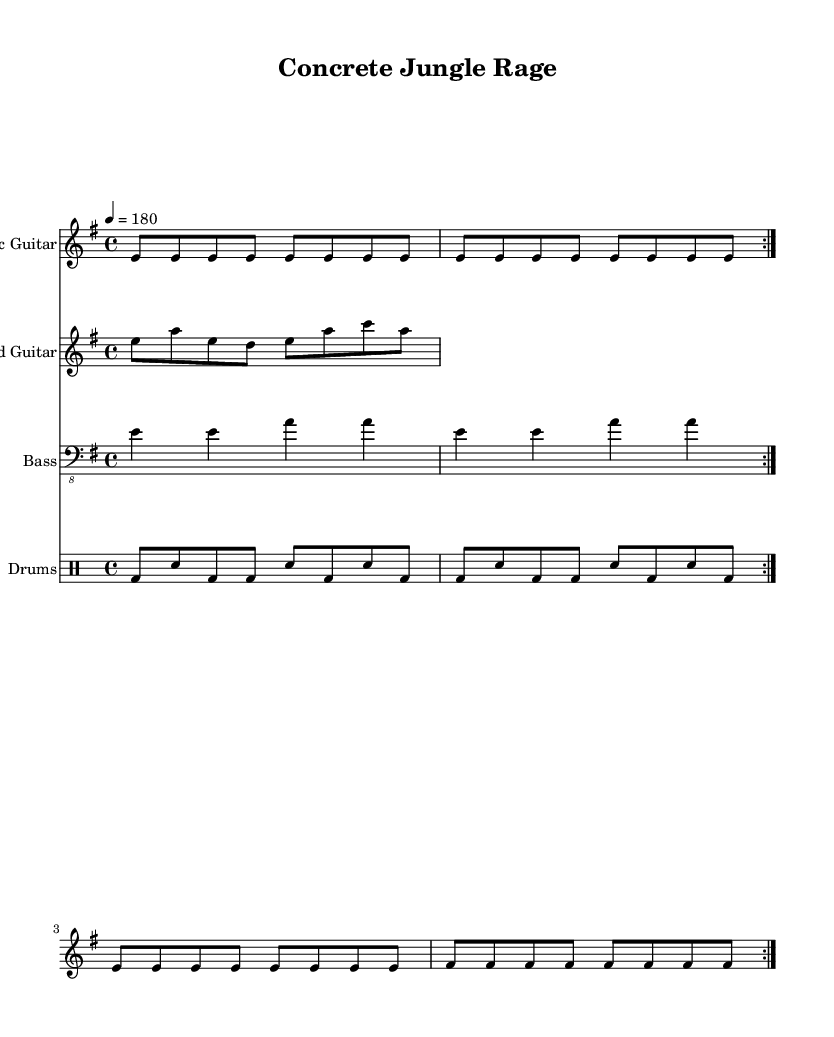What is the key signature of this music? The key signature is E minor, indicated by one sharp (F#), which is shown at the beginning of the music staff.
Answer: E minor What is the time signature of this piece? The time signature is 4/4, which means there are four beats in each measure and the quarter note gets one beat. This is visible at the start of the score where the time signature is indicated.
Answer: 4/4 What is the tempo marking in this sheet music? The tempo marking is 180 beats per minute, specified in the score as "4 = 180," which informs the performer how fast to play the piece.
Answer: 180 How many measures are there in the electric guitar part? The electric guitar part consists of 16 measures, as indicated by the repeated sections and the structure of the notated rhythms.
Answer: 16 In which musical style is this song composed? The song is composed in the thrash metal style, characterized by its fast tempo, aggressive guitar riffs, and heavy drumming, which aligns with the typical elements of thrash metal music.
Answer: Thrash metal How many different instruments are featured in this piece? There are four different instruments featured: electric guitar, lead guitar, bass, and drums, as indicated by the separate staves for each instrument in the score.
Answer: Four 